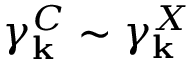Convert formula to latex. <formula><loc_0><loc_0><loc_500><loc_500>\gamma _ { k } ^ { C } \sim \gamma _ { k } ^ { X }</formula> 